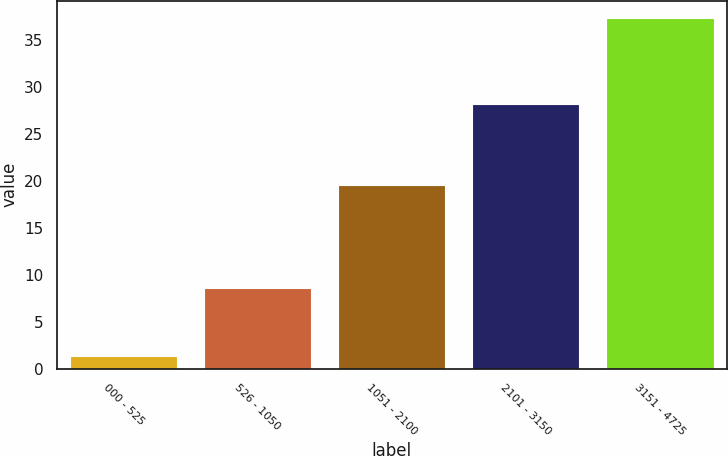Convert chart. <chart><loc_0><loc_0><loc_500><loc_500><bar_chart><fcel>000 - 525<fcel>526 - 1050<fcel>1051 - 2100<fcel>2101 - 3150<fcel>3151 - 4725<nl><fcel>1.32<fcel>8.56<fcel>19.53<fcel>28.14<fcel>37.3<nl></chart> 